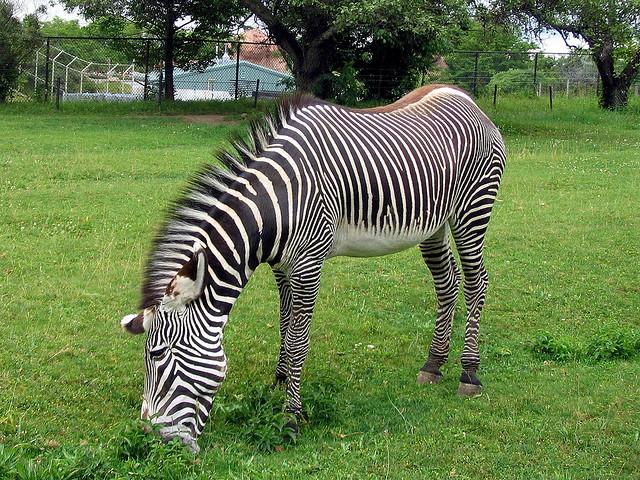What is the animal eating?
Short answer required. Grass. How many stripes are there?
Concise answer only. 50. What kind of animal is this?
Be succinct. Zebra. Can you see the zebras butt?
Write a very short answer. No. 